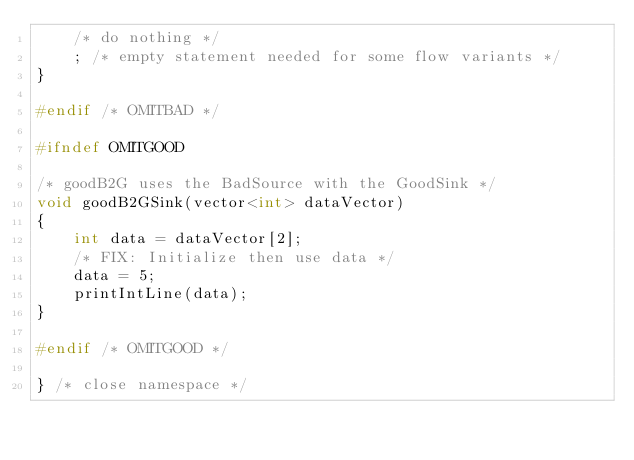Convert code to text. <code><loc_0><loc_0><loc_500><loc_500><_C++_>    /* do nothing */
    ; /* empty statement needed for some flow variants */
}

#endif /* OMITBAD */

#ifndef OMITGOOD

/* goodB2G uses the BadSource with the GoodSink */
void goodB2GSink(vector<int> dataVector)
{
    int data = dataVector[2];
    /* FIX: Initialize then use data */
    data = 5;
    printIntLine(data);
}

#endif /* OMITGOOD */

} /* close namespace */
</code> 